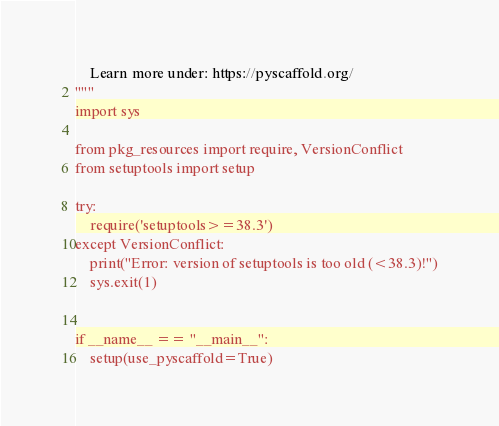Convert code to text. <code><loc_0><loc_0><loc_500><loc_500><_Python_>    Learn more under: https://pyscaffold.org/
"""
import sys

from pkg_resources import require, VersionConflict
from setuptools import setup

try:
    require('setuptools>=38.3')
except VersionConflict:
    print("Error: version of setuptools is too old (<38.3)!")
    sys.exit(1)


if __name__ == "__main__":
    setup(use_pyscaffold=True)
</code> 